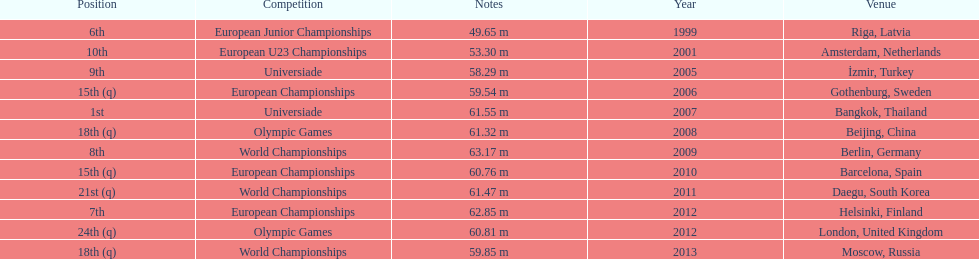How many world championships has he been in? 3. Could you parse the entire table as a dict? {'header': ['Position', 'Competition', 'Notes', 'Year', 'Venue'], 'rows': [['6th', 'European Junior Championships', '49.65 m', '1999', 'Riga, Latvia'], ['10th', 'European U23 Championships', '53.30 m', '2001', 'Amsterdam, Netherlands'], ['9th', 'Universiade', '58.29 m', '2005', 'İzmir, Turkey'], ['15th (q)', 'European Championships', '59.54 m', '2006', 'Gothenburg, Sweden'], ['1st', 'Universiade', '61.55 m', '2007', 'Bangkok, Thailand'], ['18th (q)', 'Olympic Games', '61.32 m', '2008', 'Beijing, China'], ['8th', 'World Championships', '63.17 m', '2009', 'Berlin, Germany'], ['15th (q)', 'European Championships', '60.76 m', '2010', 'Barcelona, Spain'], ['21st (q)', 'World Championships', '61.47 m', '2011', 'Daegu, South Korea'], ['7th', 'European Championships', '62.85 m', '2012', 'Helsinki, Finland'], ['24th (q)', 'Olympic Games', '60.81 m', '2012', 'London, United Kingdom'], ['18th (q)', 'World Championships', '59.85 m', '2013', 'Moscow, Russia']]} 